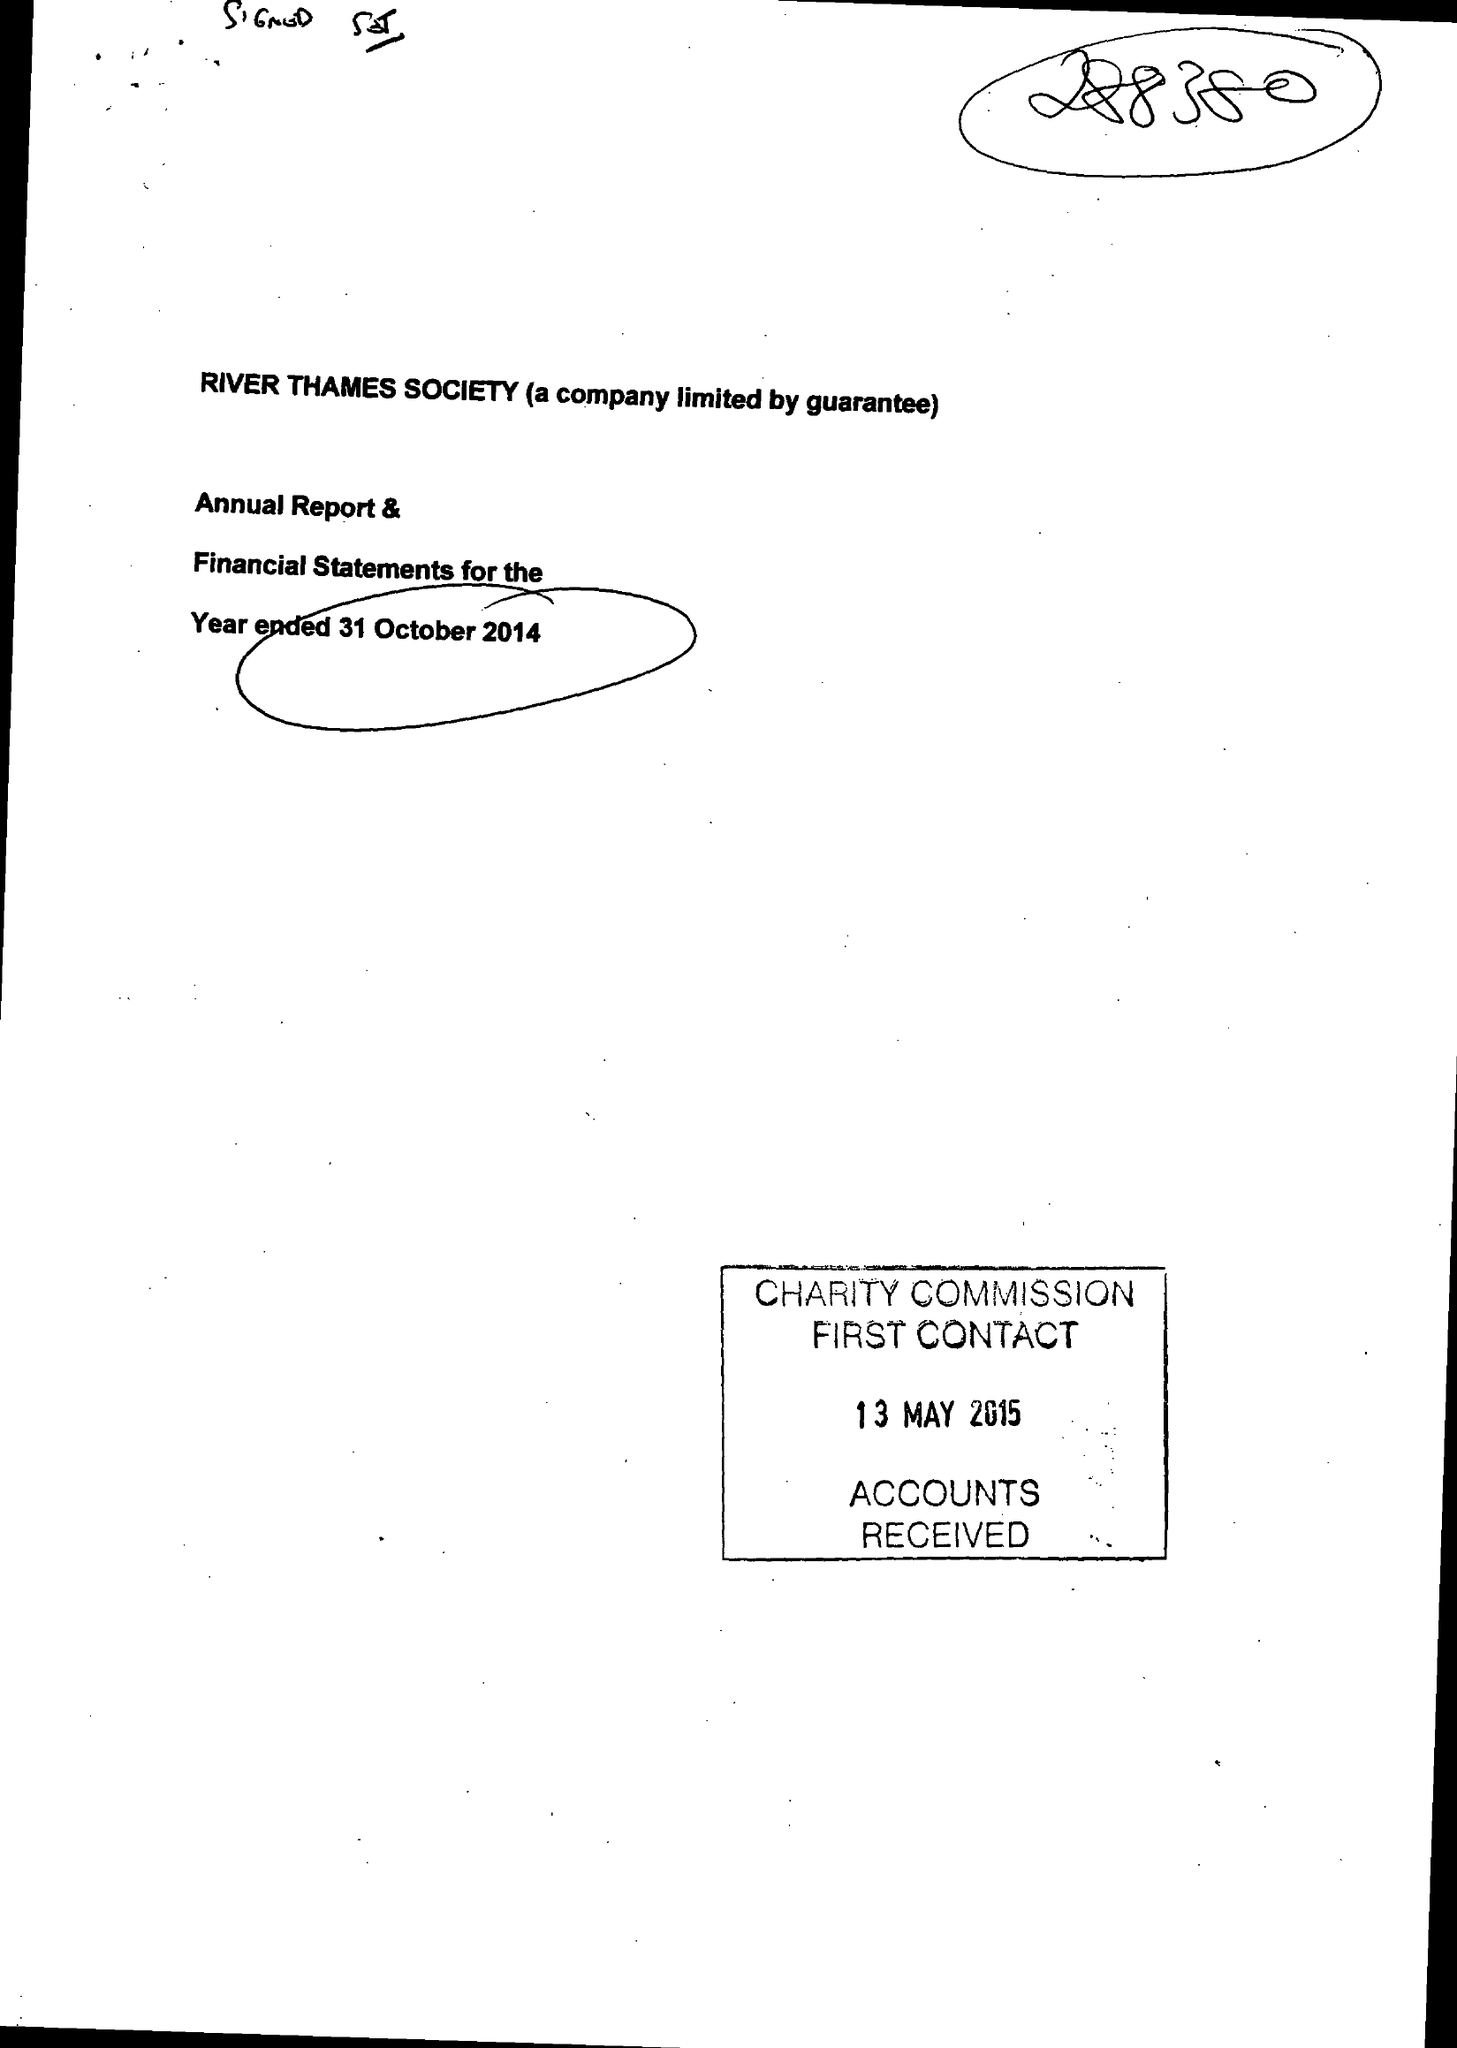What is the value for the charity_number?
Answer the question using a single word or phrase. 288380 